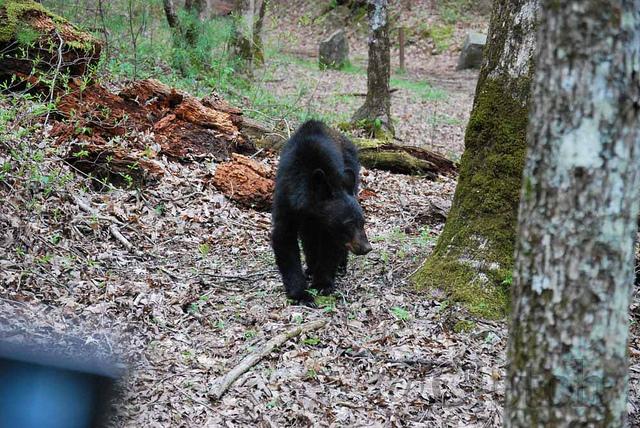Are there any man-made objects visible in this image?
Concise answer only. Yes. What kind of bear is pictured?
Keep it brief. Black. Is the bear looking for food?
Answer briefly. Yes. 